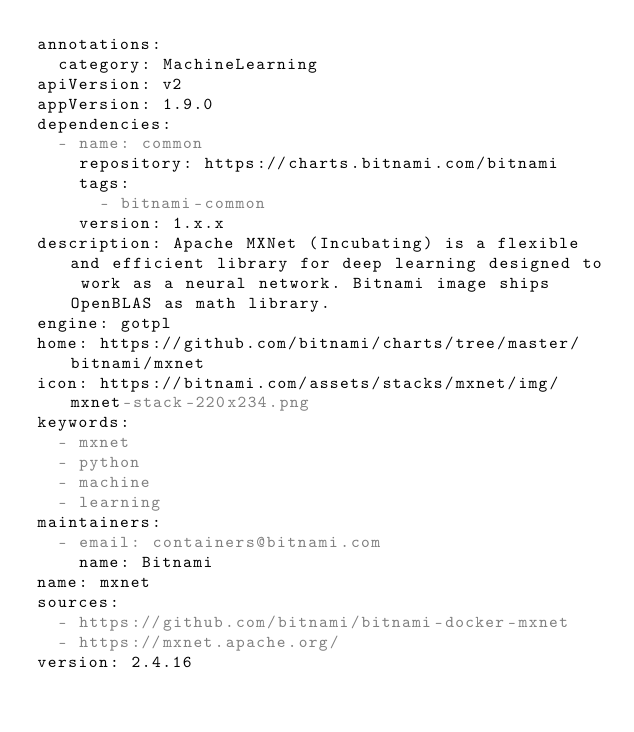Convert code to text. <code><loc_0><loc_0><loc_500><loc_500><_YAML_>annotations:
  category: MachineLearning
apiVersion: v2
appVersion: 1.9.0
dependencies:
  - name: common
    repository: https://charts.bitnami.com/bitnami
    tags:
      - bitnami-common
    version: 1.x.x
description: Apache MXNet (Incubating) is a flexible and efficient library for deep learning designed to work as a neural network. Bitnami image ships OpenBLAS as math library.
engine: gotpl
home: https://github.com/bitnami/charts/tree/master/bitnami/mxnet
icon: https://bitnami.com/assets/stacks/mxnet/img/mxnet-stack-220x234.png
keywords:
  - mxnet
  - python
  - machine
  - learning
maintainers:
  - email: containers@bitnami.com
    name: Bitnami
name: mxnet
sources:
  - https://github.com/bitnami/bitnami-docker-mxnet
  - https://mxnet.apache.org/
version: 2.4.16
</code> 